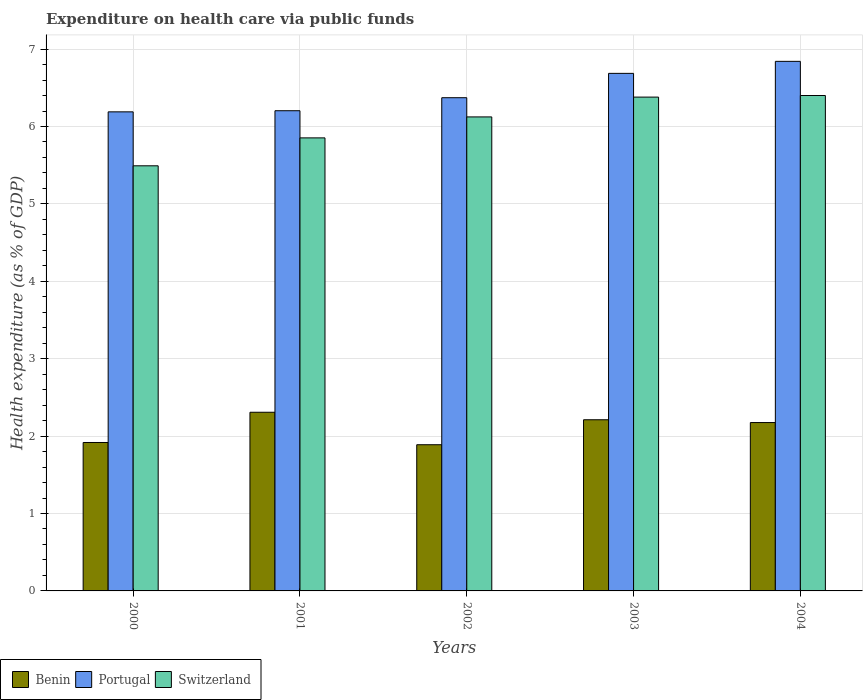How many different coloured bars are there?
Ensure brevity in your answer.  3. Are the number of bars per tick equal to the number of legend labels?
Your response must be concise. Yes. What is the label of the 5th group of bars from the left?
Give a very brief answer. 2004. In how many cases, is the number of bars for a given year not equal to the number of legend labels?
Ensure brevity in your answer.  0. What is the expenditure made on health care in Benin in 2003?
Offer a very short reply. 2.21. Across all years, what is the maximum expenditure made on health care in Benin?
Your answer should be compact. 2.31. Across all years, what is the minimum expenditure made on health care in Benin?
Provide a short and direct response. 1.89. In which year was the expenditure made on health care in Benin minimum?
Offer a terse response. 2002. What is the total expenditure made on health care in Benin in the graph?
Ensure brevity in your answer.  10.5. What is the difference between the expenditure made on health care in Switzerland in 2001 and that in 2003?
Make the answer very short. -0.53. What is the difference between the expenditure made on health care in Switzerland in 2000 and the expenditure made on health care in Portugal in 2003?
Give a very brief answer. -1.19. What is the average expenditure made on health care in Switzerland per year?
Offer a terse response. 6.05. In the year 2004, what is the difference between the expenditure made on health care in Benin and expenditure made on health care in Switzerland?
Provide a short and direct response. -4.23. What is the ratio of the expenditure made on health care in Benin in 2001 to that in 2004?
Give a very brief answer. 1.06. What is the difference between the highest and the second highest expenditure made on health care in Portugal?
Give a very brief answer. 0.16. What is the difference between the highest and the lowest expenditure made on health care in Portugal?
Your answer should be very brief. 0.65. In how many years, is the expenditure made on health care in Switzerland greater than the average expenditure made on health care in Switzerland taken over all years?
Give a very brief answer. 3. Is the sum of the expenditure made on health care in Benin in 2002 and 2003 greater than the maximum expenditure made on health care in Portugal across all years?
Your response must be concise. No. What does the 2nd bar from the left in 2001 represents?
Make the answer very short. Portugal. What does the 3rd bar from the right in 2001 represents?
Offer a terse response. Benin. Is it the case that in every year, the sum of the expenditure made on health care in Switzerland and expenditure made on health care in Benin is greater than the expenditure made on health care in Portugal?
Offer a terse response. Yes. How many bars are there?
Your answer should be compact. 15. Does the graph contain grids?
Offer a very short reply. Yes. How many legend labels are there?
Provide a succinct answer. 3. How are the legend labels stacked?
Offer a very short reply. Horizontal. What is the title of the graph?
Your response must be concise. Expenditure on health care via public funds. What is the label or title of the Y-axis?
Provide a short and direct response. Health expenditure (as % of GDP). What is the Health expenditure (as % of GDP) of Benin in 2000?
Your answer should be compact. 1.92. What is the Health expenditure (as % of GDP) in Portugal in 2000?
Offer a terse response. 6.19. What is the Health expenditure (as % of GDP) in Switzerland in 2000?
Your answer should be compact. 5.49. What is the Health expenditure (as % of GDP) of Benin in 2001?
Your response must be concise. 2.31. What is the Health expenditure (as % of GDP) in Portugal in 2001?
Your answer should be compact. 6.2. What is the Health expenditure (as % of GDP) in Switzerland in 2001?
Your answer should be very brief. 5.85. What is the Health expenditure (as % of GDP) in Benin in 2002?
Your answer should be very brief. 1.89. What is the Health expenditure (as % of GDP) of Portugal in 2002?
Your response must be concise. 6.37. What is the Health expenditure (as % of GDP) in Switzerland in 2002?
Offer a terse response. 6.12. What is the Health expenditure (as % of GDP) in Benin in 2003?
Provide a succinct answer. 2.21. What is the Health expenditure (as % of GDP) in Portugal in 2003?
Make the answer very short. 6.69. What is the Health expenditure (as % of GDP) in Switzerland in 2003?
Give a very brief answer. 6.38. What is the Health expenditure (as % of GDP) of Benin in 2004?
Offer a very short reply. 2.18. What is the Health expenditure (as % of GDP) of Portugal in 2004?
Ensure brevity in your answer.  6.84. What is the Health expenditure (as % of GDP) of Switzerland in 2004?
Offer a terse response. 6.4. Across all years, what is the maximum Health expenditure (as % of GDP) in Benin?
Make the answer very short. 2.31. Across all years, what is the maximum Health expenditure (as % of GDP) of Portugal?
Provide a short and direct response. 6.84. Across all years, what is the maximum Health expenditure (as % of GDP) of Switzerland?
Make the answer very short. 6.4. Across all years, what is the minimum Health expenditure (as % of GDP) in Benin?
Your answer should be very brief. 1.89. Across all years, what is the minimum Health expenditure (as % of GDP) in Portugal?
Offer a very short reply. 6.19. Across all years, what is the minimum Health expenditure (as % of GDP) in Switzerland?
Your answer should be compact. 5.49. What is the total Health expenditure (as % of GDP) of Benin in the graph?
Give a very brief answer. 10.5. What is the total Health expenditure (as % of GDP) of Portugal in the graph?
Provide a short and direct response. 32.29. What is the total Health expenditure (as % of GDP) in Switzerland in the graph?
Your answer should be very brief. 30.25. What is the difference between the Health expenditure (as % of GDP) in Benin in 2000 and that in 2001?
Your response must be concise. -0.39. What is the difference between the Health expenditure (as % of GDP) in Portugal in 2000 and that in 2001?
Provide a succinct answer. -0.01. What is the difference between the Health expenditure (as % of GDP) of Switzerland in 2000 and that in 2001?
Make the answer very short. -0.36. What is the difference between the Health expenditure (as % of GDP) in Benin in 2000 and that in 2002?
Provide a succinct answer. 0.03. What is the difference between the Health expenditure (as % of GDP) of Portugal in 2000 and that in 2002?
Your answer should be very brief. -0.18. What is the difference between the Health expenditure (as % of GDP) of Switzerland in 2000 and that in 2002?
Offer a very short reply. -0.63. What is the difference between the Health expenditure (as % of GDP) in Benin in 2000 and that in 2003?
Your response must be concise. -0.29. What is the difference between the Health expenditure (as % of GDP) of Portugal in 2000 and that in 2003?
Offer a very short reply. -0.5. What is the difference between the Health expenditure (as % of GDP) in Switzerland in 2000 and that in 2003?
Provide a short and direct response. -0.89. What is the difference between the Health expenditure (as % of GDP) in Benin in 2000 and that in 2004?
Give a very brief answer. -0.26. What is the difference between the Health expenditure (as % of GDP) in Portugal in 2000 and that in 2004?
Keep it short and to the point. -0.65. What is the difference between the Health expenditure (as % of GDP) of Switzerland in 2000 and that in 2004?
Make the answer very short. -0.91. What is the difference between the Health expenditure (as % of GDP) in Benin in 2001 and that in 2002?
Ensure brevity in your answer.  0.42. What is the difference between the Health expenditure (as % of GDP) of Portugal in 2001 and that in 2002?
Your answer should be compact. -0.17. What is the difference between the Health expenditure (as % of GDP) in Switzerland in 2001 and that in 2002?
Your answer should be very brief. -0.27. What is the difference between the Health expenditure (as % of GDP) of Benin in 2001 and that in 2003?
Your answer should be compact. 0.1. What is the difference between the Health expenditure (as % of GDP) in Portugal in 2001 and that in 2003?
Offer a very short reply. -0.48. What is the difference between the Health expenditure (as % of GDP) in Switzerland in 2001 and that in 2003?
Your answer should be very brief. -0.53. What is the difference between the Health expenditure (as % of GDP) of Benin in 2001 and that in 2004?
Your response must be concise. 0.13. What is the difference between the Health expenditure (as % of GDP) in Portugal in 2001 and that in 2004?
Offer a very short reply. -0.64. What is the difference between the Health expenditure (as % of GDP) in Switzerland in 2001 and that in 2004?
Provide a succinct answer. -0.55. What is the difference between the Health expenditure (as % of GDP) of Benin in 2002 and that in 2003?
Ensure brevity in your answer.  -0.32. What is the difference between the Health expenditure (as % of GDP) of Portugal in 2002 and that in 2003?
Ensure brevity in your answer.  -0.31. What is the difference between the Health expenditure (as % of GDP) of Switzerland in 2002 and that in 2003?
Provide a succinct answer. -0.26. What is the difference between the Health expenditure (as % of GDP) in Benin in 2002 and that in 2004?
Ensure brevity in your answer.  -0.29. What is the difference between the Health expenditure (as % of GDP) in Portugal in 2002 and that in 2004?
Your response must be concise. -0.47. What is the difference between the Health expenditure (as % of GDP) of Switzerland in 2002 and that in 2004?
Offer a terse response. -0.28. What is the difference between the Health expenditure (as % of GDP) in Benin in 2003 and that in 2004?
Your answer should be compact. 0.04. What is the difference between the Health expenditure (as % of GDP) of Portugal in 2003 and that in 2004?
Give a very brief answer. -0.16. What is the difference between the Health expenditure (as % of GDP) in Switzerland in 2003 and that in 2004?
Ensure brevity in your answer.  -0.02. What is the difference between the Health expenditure (as % of GDP) in Benin in 2000 and the Health expenditure (as % of GDP) in Portugal in 2001?
Provide a short and direct response. -4.29. What is the difference between the Health expenditure (as % of GDP) of Benin in 2000 and the Health expenditure (as % of GDP) of Switzerland in 2001?
Give a very brief answer. -3.94. What is the difference between the Health expenditure (as % of GDP) in Portugal in 2000 and the Health expenditure (as % of GDP) in Switzerland in 2001?
Your response must be concise. 0.34. What is the difference between the Health expenditure (as % of GDP) in Benin in 2000 and the Health expenditure (as % of GDP) in Portugal in 2002?
Ensure brevity in your answer.  -4.45. What is the difference between the Health expenditure (as % of GDP) in Benin in 2000 and the Health expenditure (as % of GDP) in Switzerland in 2002?
Provide a short and direct response. -4.21. What is the difference between the Health expenditure (as % of GDP) of Portugal in 2000 and the Health expenditure (as % of GDP) of Switzerland in 2002?
Your answer should be compact. 0.07. What is the difference between the Health expenditure (as % of GDP) of Benin in 2000 and the Health expenditure (as % of GDP) of Portugal in 2003?
Offer a very short reply. -4.77. What is the difference between the Health expenditure (as % of GDP) of Benin in 2000 and the Health expenditure (as % of GDP) of Switzerland in 2003?
Make the answer very short. -4.46. What is the difference between the Health expenditure (as % of GDP) in Portugal in 2000 and the Health expenditure (as % of GDP) in Switzerland in 2003?
Your response must be concise. -0.19. What is the difference between the Health expenditure (as % of GDP) of Benin in 2000 and the Health expenditure (as % of GDP) of Portugal in 2004?
Provide a short and direct response. -4.92. What is the difference between the Health expenditure (as % of GDP) in Benin in 2000 and the Health expenditure (as % of GDP) in Switzerland in 2004?
Give a very brief answer. -4.48. What is the difference between the Health expenditure (as % of GDP) in Portugal in 2000 and the Health expenditure (as % of GDP) in Switzerland in 2004?
Ensure brevity in your answer.  -0.21. What is the difference between the Health expenditure (as % of GDP) of Benin in 2001 and the Health expenditure (as % of GDP) of Portugal in 2002?
Ensure brevity in your answer.  -4.06. What is the difference between the Health expenditure (as % of GDP) in Benin in 2001 and the Health expenditure (as % of GDP) in Switzerland in 2002?
Your answer should be compact. -3.82. What is the difference between the Health expenditure (as % of GDP) in Portugal in 2001 and the Health expenditure (as % of GDP) in Switzerland in 2002?
Provide a succinct answer. 0.08. What is the difference between the Health expenditure (as % of GDP) in Benin in 2001 and the Health expenditure (as % of GDP) in Portugal in 2003?
Provide a short and direct response. -4.38. What is the difference between the Health expenditure (as % of GDP) in Benin in 2001 and the Health expenditure (as % of GDP) in Switzerland in 2003?
Provide a short and direct response. -4.07. What is the difference between the Health expenditure (as % of GDP) of Portugal in 2001 and the Health expenditure (as % of GDP) of Switzerland in 2003?
Keep it short and to the point. -0.18. What is the difference between the Health expenditure (as % of GDP) in Benin in 2001 and the Health expenditure (as % of GDP) in Portugal in 2004?
Your answer should be compact. -4.53. What is the difference between the Health expenditure (as % of GDP) in Benin in 2001 and the Health expenditure (as % of GDP) in Switzerland in 2004?
Offer a very short reply. -4.09. What is the difference between the Health expenditure (as % of GDP) of Portugal in 2001 and the Health expenditure (as % of GDP) of Switzerland in 2004?
Provide a short and direct response. -0.2. What is the difference between the Health expenditure (as % of GDP) in Benin in 2002 and the Health expenditure (as % of GDP) in Portugal in 2003?
Provide a short and direct response. -4.8. What is the difference between the Health expenditure (as % of GDP) of Benin in 2002 and the Health expenditure (as % of GDP) of Switzerland in 2003?
Your answer should be compact. -4.49. What is the difference between the Health expenditure (as % of GDP) in Portugal in 2002 and the Health expenditure (as % of GDP) in Switzerland in 2003?
Your answer should be compact. -0.01. What is the difference between the Health expenditure (as % of GDP) of Benin in 2002 and the Health expenditure (as % of GDP) of Portugal in 2004?
Your answer should be very brief. -4.95. What is the difference between the Health expenditure (as % of GDP) of Benin in 2002 and the Health expenditure (as % of GDP) of Switzerland in 2004?
Provide a short and direct response. -4.51. What is the difference between the Health expenditure (as % of GDP) of Portugal in 2002 and the Health expenditure (as % of GDP) of Switzerland in 2004?
Ensure brevity in your answer.  -0.03. What is the difference between the Health expenditure (as % of GDP) of Benin in 2003 and the Health expenditure (as % of GDP) of Portugal in 2004?
Offer a terse response. -4.63. What is the difference between the Health expenditure (as % of GDP) of Benin in 2003 and the Health expenditure (as % of GDP) of Switzerland in 2004?
Your answer should be compact. -4.19. What is the difference between the Health expenditure (as % of GDP) in Portugal in 2003 and the Health expenditure (as % of GDP) in Switzerland in 2004?
Offer a terse response. 0.29. What is the average Health expenditure (as % of GDP) in Benin per year?
Provide a short and direct response. 2.1. What is the average Health expenditure (as % of GDP) of Portugal per year?
Provide a short and direct response. 6.46. What is the average Health expenditure (as % of GDP) in Switzerland per year?
Offer a terse response. 6.05. In the year 2000, what is the difference between the Health expenditure (as % of GDP) in Benin and Health expenditure (as % of GDP) in Portugal?
Your response must be concise. -4.27. In the year 2000, what is the difference between the Health expenditure (as % of GDP) in Benin and Health expenditure (as % of GDP) in Switzerland?
Your answer should be very brief. -3.57. In the year 2000, what is the difference between the Health expenditure (as % of GDP) of Portugal and Health expenditure (as % of GDP) of Switzerland?
Your response must be concise. 0.7. In the year 2001, what is the difference between the Health expenditure (as % of GDP) of Benin and Health expenditure (as % of GDP) of Portugal?
Your response must be concise. -3.9. In the year 2001, what is the difference between the Health expenditure (as % of GDP) in Benin and Health expenditure (as % of GDP) in Switzerland?
Your answer should be compact. -3.54. In the year 2001, what is the difference between the Health expenditure (as % of GDP) in Portugal and Health expenditure (as % of GDP) in Switzerland?
Your response must be concise. 0.35. In the year 2002, what is the difference between the Health expenditure (as % of GDP) in Benin and Health expenditure (as % of GDP) in Portugal?
Provide a succinct answer. -4.48. In the year 2002, what is the difference between the Health expenditure (as % of GDP) of Benin and Health expenditure (as % of GDP) of Switzerland?
Keep it short and to the point. -4.24. In the year 2002, what is the difference between the Health expenditure (as % of GDP) in Portugal and Health expenditure (as % of GDP) in Switzerland?
Offer a terse response. 0.25. In the year 2003, what is the difference between the Health expenditure (as % of GDP) of Benin and Health expenditure (as % of GDP) of Portugal?
Your answer should be compact. -4.47. In the year 2003, what is the difference between the Health expenditure (as % of GDP) of Benin and Health expenditure (as % of GDP) of Switzerland?
Provide a succinct answer. -4.17. In the year 2003, what is the difference between the Health expenditure (as % of GDP) of Portugal and Health expenditure (as % of GDP) of Switzerland?
Make the answer very short. 0.31. In the year 2004, what is the difference between the Health expenditure (as % of GDP) of Benin and Health expenditure (as % of GDP) of Portugal?
Provide a short and direct response. -4.67. In the year 2004, what is the difference between the Health expenditure (as % of GDP) in Benin and Health expenditure (as % of GDP) in Switzerland?
Offer a terse response. -4.23. In the year 2004, what is the difference between the Health expenditure (as % of GDP) of Portugal and Health expenditure (as % of GDP) of Switzerland?
Ensure brevity in your answer.  0.44. What is the ratio of the Health expenditure (as % of GDP) of Benin in 2000 to that in 2001?
Provide a succinct answer. 0.83. What is the ratio of the Health expenditure (as % of GDP) of Switzerland in 2000 to that in 2001?
Make the answer very short. 0.94. What is the ratio of the Health expenditure (as % of GDP) in Benin in 2000 to that in 2002?
Provide a short and direct response. 1.02. What is the ratio of the Health expenditure (as % of GDP) in Portugal in 2000 to that in 2002?
Your response must be concise. 0.97. What is the ratio of the Health expenditure (as % of GDP) of Switzerland in 2000 to that in 2002?
Give a very brief answer. 0.9. What is the ratio of the Health expenditure (as % of GDP) of Benin in 2000 to that in 2003?
Keep it short and to the point. 0.87. What is the ratio of the Health expenditure (as % of GDP) in Portugal in 2000 to that in 2003?
Provide a short and direct response. 0.93. What is the ratio of the Health expenditure (as % of GDP) in Switzerland in 2000 to that in 2003?
Provide a succinct answer. 0.86. What is the ratio of the Health expenditure (as % of GDP) of Benin in 2000 to that in 2004?
Offer a very short reply. 0.88. What is the ratio of the Health expenditure (as % of GDP) in Portugal in 2000 to that in 2004?
Keep it short and to the point. 0.9. What is the ratio of the Health expenditure (as % of GDP) of Switzerland in 2000 to that in 2004?
Make the answer very short. 0.86. What is the ratio of the Health expenditure (as % of GDP) of Benin in 2001 to that in 2002?
Your response must be concise. 1.22. What is the ratio of the Health expenditure (as % of GDP) in Portugal in 2001 to that in 2002?
Make the answer very short. 0.97. What is the ratio of the Health expenditure (as % of GDP) in Switzerland in 2001 to that in 2002?
Offer a terse response. 0.96. What is the ratio of the Health expenditure (as % of GDP) in Benin in 2001 to that in 2003?
Your answer should be very brief. 1.04. What is the ratio of the Health expenditure (as % of GDP) of Portugal in 2001 to that in 2003?
Your response must be concise. 0.93. What is the ratio of the Health expenditure (as % of GDP) in Switzerland in 2001 to that in 2003?
Make the answer very short. 0.92. What is the ratio of the Health expenditure (as % of GDP) in Benin in 2001 to that in 2004?
Ensure brevity in your answer.  1.06. What is the ratio of the Health expenditure (as % of GDP) in Portugal in 2001 to that in 2004?
Ensure brevity in your answer.  0.91. What is the ratio of the Health expenditure (as % of GDP) of Switzerland in 2001 to that in 2004?
Offer a very short reply. 0.91. What is the ratio of the Health expenditure (as % of GDP) in Benin in 2002 to that in 2003?
Make the answer very short. 0.85. What is the ratio of the Health expenditure (as % of GDP) of Portugal in 2002 to that in 2003?
Make the answer very short. 0.95. What is the ratio of the Health expenditure (as % of GDP) in Switzerland in 2002 to that in 2003?
Keep it short and to the point. 0.96. What is the ratio of the Health expenditure (as % of GDP) of Benin in 2002 to that in 2004?
Your answer should be compact. 0.87. What is the ratio of the Health expenditure (as % of GDP) in Portugal in 2002 to that in 2004?
Provide a short and direct response. 0.93. What is the ratio of the Health expenditure (as % of GDP) of Switzerland in 2002 to that in 2004?
Offer a very short reply. 0.96. What is the ratio of the Health expenditure (as % of GDP) of Benin in 2003 to that in 2004?
Give a very brief answer. 1.02. What is the ratio of the Health expenditure (as % of GDP) of Portugal in 2003 to that in 2004?
Make the answer very short. 0.98. What is the difference between the highest and the second highest Health expenditure (as % of GDP) of Benin?
Provide a short and direct response. 0.1. What is the difference between the highest and the second highest Health expenditure (as % of GDP) of Portugal?
Provide a succinct answer. 0.16. What is the difference between the highest and the second highest Health expenditure (as % of GDP) in Switzerland?
Your answer should be compact. 0.02. What is the difference between the highest and the lowest Health expenditure (as % of GDP) in Benin?
Provide a succinct answer. 0.42. What is the difference between the highest and the lowest Health expenditure (as % of GDP) of Portugal?
Your response must be concise. 0.65. What is the difference between the highest and the lowest Health expenditure (as % of GDP) in Switzerland?
Provide a succinct answer. 0.91. 